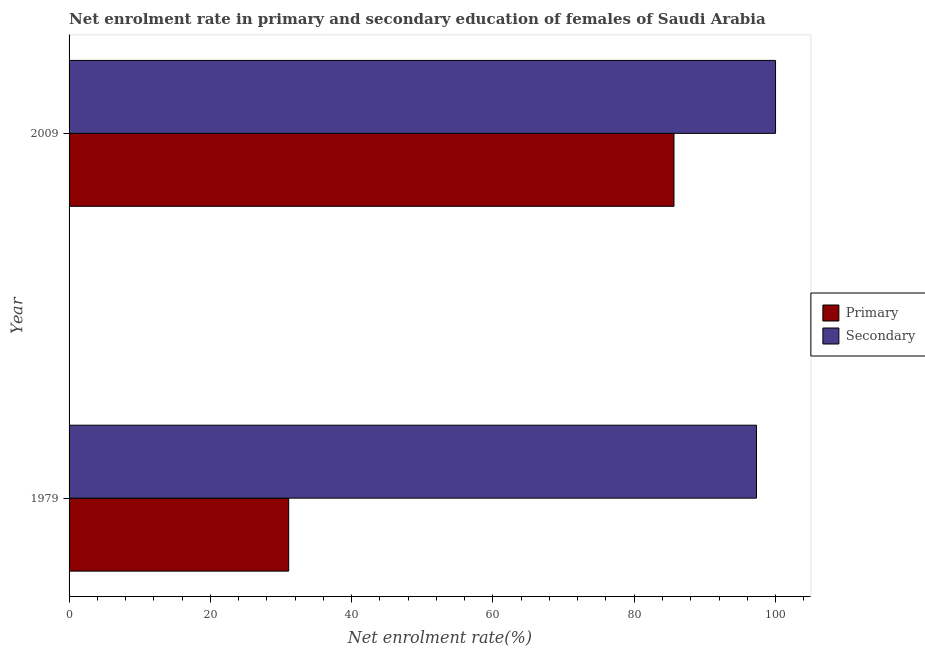How many different coloured bars are there?
Keep it short and to the point. 2. How many groups of bars are there?
Provide a succinct answer. 2. Are the number of bars per tick equal to the number of legend labels?
Your answer should be compact. Yes. How many bars are there on the 2nd tick from the top?
Give a very brief answer. 2. How many bars are there on the 1st tick from the bottom?
Your answer should be very brief. 2. What is the enrollment rate in primary education in 1979?
Provide a succinct answer. 31.09. Across all years, what is the maximum enrollment rate in primary education?
Your answer should be very brief. 85.63. Across all years, what is the minimum enrollment rate in primary education?
Make the answer very short. 31.09. In which year was the enrollment rate in secondary education maximum?
Make the answer very short. 2009. In which year was the enrollment rate in primary education minimum?
Offer a very short reply. 1979. What is the total enrollment rate in secondary education in the graph?
Offer a terse response. 197.3. What is the difference between the enrollment rate in primary education in 1979 and that in 2009?
Your response must be concise. -54.54. What is the difference between the enrollment rate in primary education in 2009 and the enrollment rate in secondary education in 1979?
Offer a very short reply. -11.68. What is the average enrollment rate in primary education per year?
Make the answer very short. 58.36. In the year 1979, what is the difference between the enrollment rate in secondary education and enrollment rate in primary education?
Offer a very short reply. 66.21. Is the enrollment rate in primary education in 1979 less than that in 2009?
Ensure brevity in your answer.  Yes. Is the difference between the enrollment rate in secondary education in 1979 and 2009 greater than the difference between the enrollment rate in primary education in 1979 and 2009?
Offer a very short reply. Yes. In how many years, is the enrollment rate in primary education greater than the average enrollment rate in primary education taken over all years?
Your response must be concise. 1. What does the 2nd bar from the top in 2009 represents?
Offer a terse response. Primary. What does the 2nd bar from the bottom in 2009 represents?
Provide a short and direct response. Secondary. Are all the bars in the graph horizontal?
Offer a terse response. Yes. How many years are there in the graph?
Provide a short and direct response. 2. What is the difference between two consecutive major ticks on the X-axis?
Your answer should be compact. 20. Does the graph contain any zero values?
Offer a terse response. No. Does the graph contain grids?
Ensure brevity in your answer.  No. How are the legend labels stacked?
Make the answer very short. Vertical. What is the title of the graph?
Provide a short and direct response. Net enrolment rate in primary and secondary education of females of Saudi Arabia. What is the label or title of the X-axis?
Make the answer very short. Net enrolment rate(%). What is the label or title of the Y-axis?
Your response must be concise. Year. What is the Net enrolment rate(%) of Primary in 1979?
Your answer should be compact. 31.09. What is the Net enrolment rate(%) in Secondary in 1979?
Offer a very short reply. 97.3. What is the Net enrolment rate(%) of Primary in 2009?
Provide a succinct answer. 85.63. Across all years, what is the maximum Net enrolment rate(%) of Primary?
Your answer should be very brief. 85.63. Across all years, what is the minimum Net enrolment rate(%) in Primary?
Your response must be concise. 31.09. Across all years, what is the minimum Net enrolment rate(%) in Secondary?
Ensure brevity in your answer.  97.3. What is the total Net enrolment rate(%) in Primary in the graph?
Give a very brief answer. 116.71. What is the total Net enrolment rate(%) in Secondary in the graph?
Provide a succinct answer. 197.3. What is the difference between the Net enrolment rate(%) of Primary in 1979 and that in 2009?
Your answer should be very brief. -54.54. What is the difference between the Net enrolment rate(%) in Secondary in 1979 and that in 2009?
Provide a short and direct response. -2.7. What is the difference between the Net enrolment rate(%) in Primary in 1979 and the Net enrolment rate(%) in Secondary in 2009?
Ensure brevity in your answer.  -68.91. What is the average Net enrolment rate(%) in Primary per year?
Make the answer very short. 58.36. What is the average Net enrolment rate(%) in Secondary per year?
Ensure brevity in your answer.  98.65. In the year 1979, what is the difference between the Net enrolment rate(%) in Primary and Net enrolment rate(%) in Secondary?
Ensure brevity in your answer.  -66.21. In the year 2009, what is the difference between the Net enrolment rate(%) in Primary and Net enrolment rate(%) in Secondary?
Give a very brief answer. -14.37. What is the ratio of the Net enrolment rate(%) of Primary in 1979 to that in 2009?
Offer a terse response. 0.36. What is the ratio of the Net enrolment rate(%) in Secondary in 1979 to that in 2009?
Offer a terse response. 0.97. What is the difference between the highest and the second highest Net enrolment rate(%) of Primary?
Keep it short and to the point. 54.54. What is the difference between the highest and the second highest Net enrolment rate(%) of Secondary?
Offer a terse response. 2.7. What is the difference between the highest and the lowest Net enrolment rate(%) in Primary?
Keep it short and to the point. 54.54. What is the difference between the highest and the lowest Net enrolment rate(%) in Secondary?
Your answer should be compact. 2.7. 